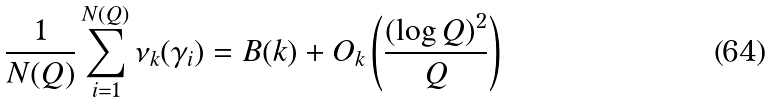<formula> <loc_0><loc_0><loc_500><loc_500>\frac { 1 } { N ( Q ) } \sum _ { i = 1 } ^ { N ( Q ) } \nu _ { k } ( \gamma _ { i } ) = B ( k ) + O _ { k } \left ( \frac { ( \log Q ) ^ { 2 } } { Q } \right )</formula> 